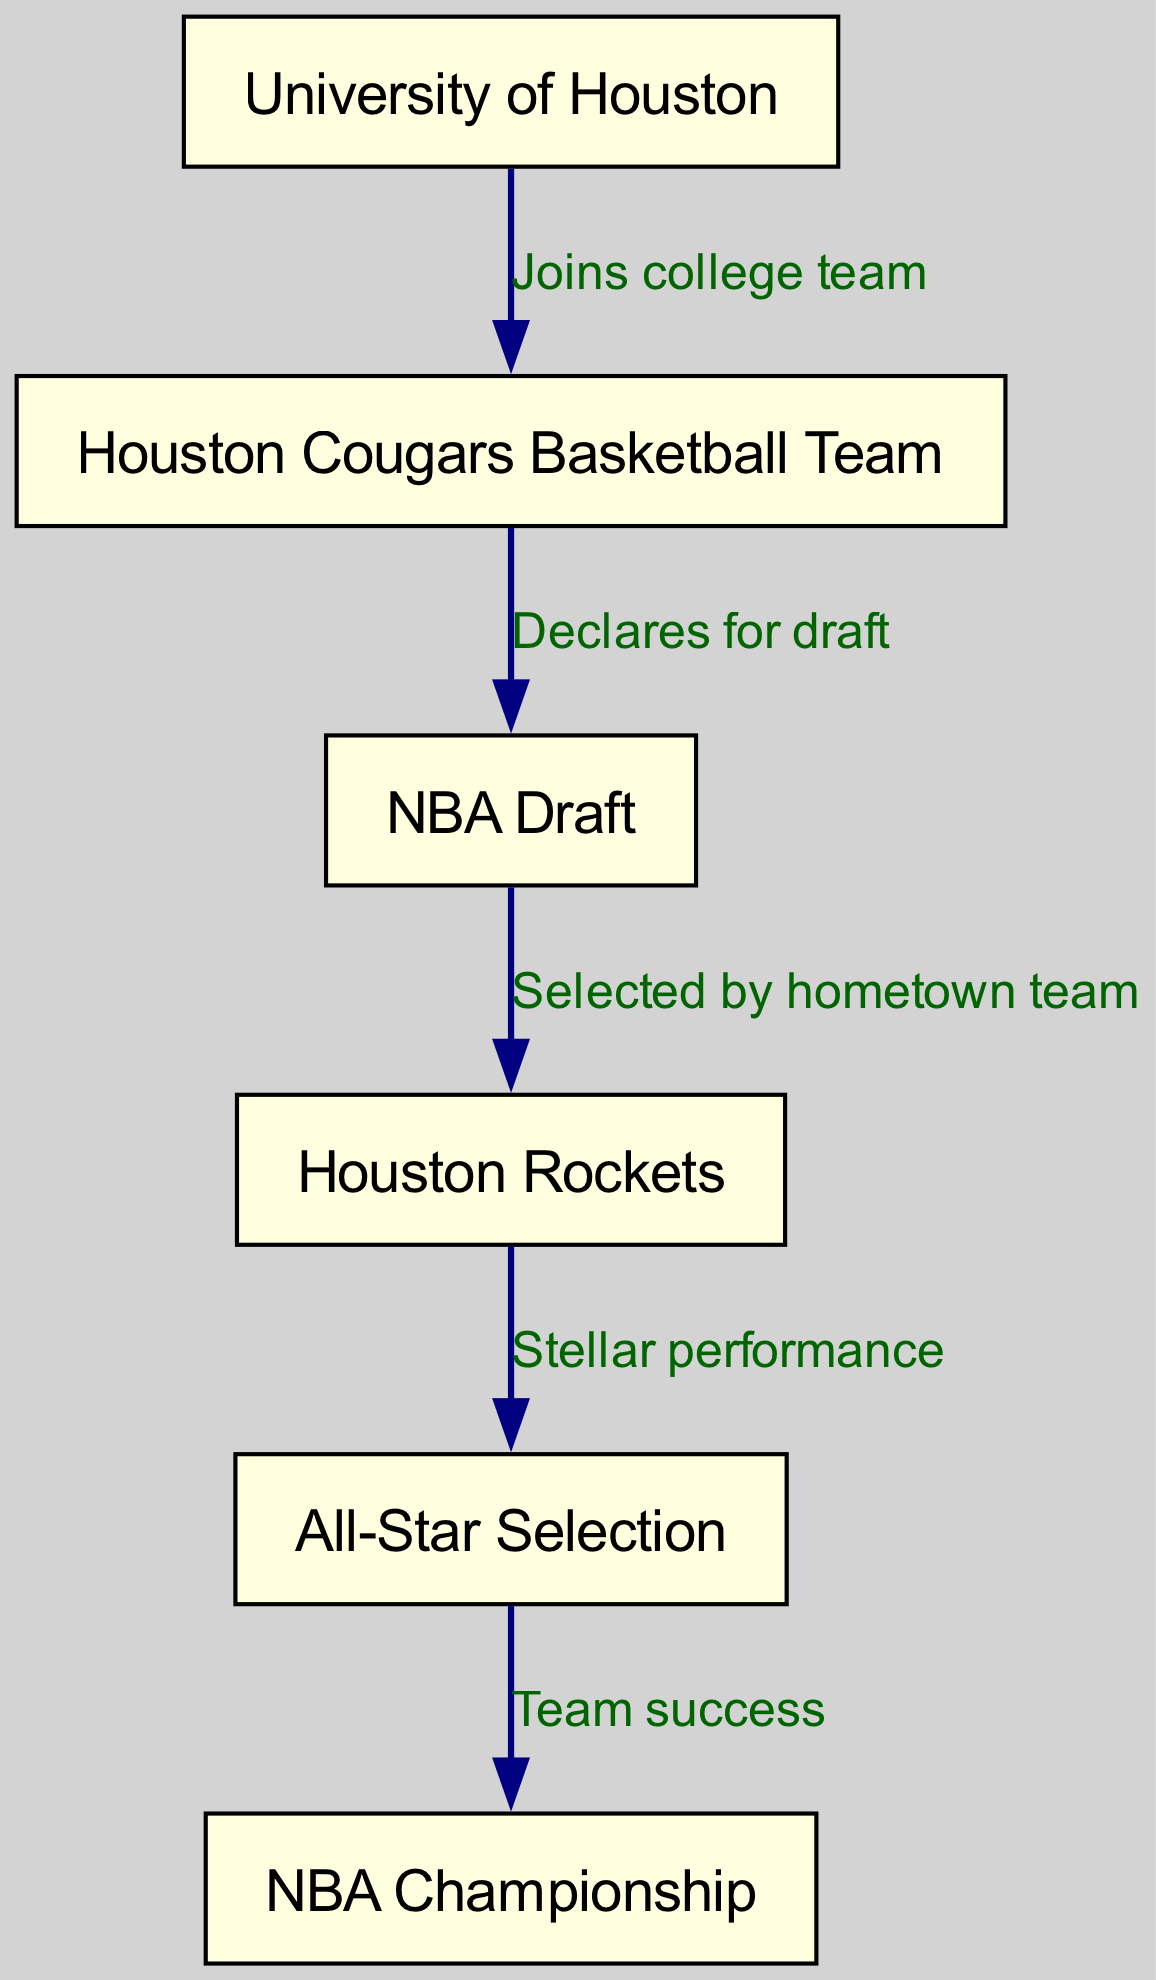What is the starting point of Ira's career progression? The first node in the flow chart represents the starting point, which is "University of Houston".
Answer: University of Houston What team did Ira join while in college? The edge from the "University of Houston" node to the "Houston Cougars Basketball Team" indicates that he joined this team.
Answer: Houston Cougars Basketball Team In what year did Ira declare for the NBA Draft? The flow proceeds from the "Houston Cougars Basketball Team" to the "NBA Draft", indicating that declaring for the draft follows his collegiate career. The exact year isn't specified but is implied to be after college.
Answer: NBA Draft Who selected Ira in the NBA Draft? The connection from the "NBA Draft" to the "Houston Rockets" reveals that he was selected by his hometown team, the Houston Rockets.
Answer: Houston Rockets What is the significance of Ira's performance in his professional career? The edge from "Houston Rockets" to "All-Star Selection" indicates that his performance was stellar enough to earn him an All-Star selection.
Answer: Stellar performance What achievement follows Ira's All-Star selection? The flow from "All-Star Selection" to "NBA Championship" shows that team success is a subsequent achievement after being selected as an All-Star.
Answer: Team success How many edges are there in Ira's career progression diagram? Counting the connections or edges in the diagram from one node to another indicates the number of relationships, which totals five edges.
Answer: Five edges What type of chart is used to depict Ira's career progression? The structure of the illustration and the connections between nodes suggests that it is a flow chart, focusing on the progression over time and events.
Answer: Flow chart 